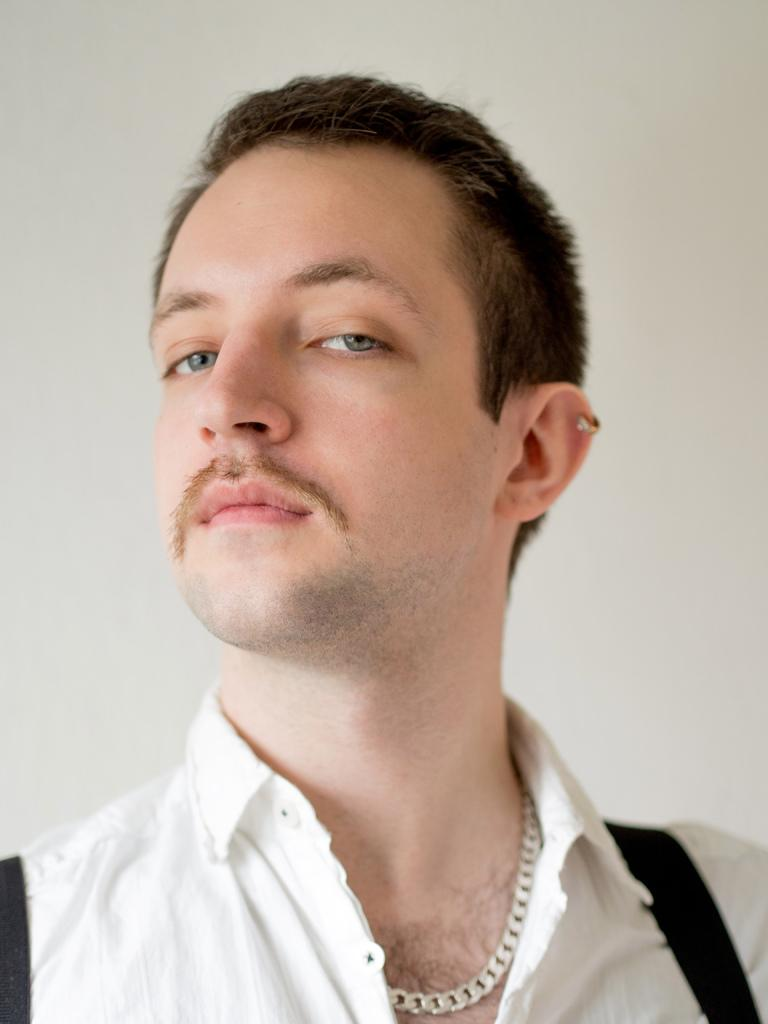Who is the main subject in the image? There is a man in the image. Where is the man positioned in the image? The man is in the front of the image. What is the man wearing on his upper body? The man is wearing a white shirt. What type of accessory is the man wearing around his neck? The man is wearing a necklace. What color can be seen in the background of the image? There is white color visible in the background of the image. How does the man maintain a quiet environment in the image? There is no information about the man's actions or the environment in the image, so it cannot be determined if he is maintaining a quiet environment. What type of sponge is visible in the image? There is no sponge present in the image. 